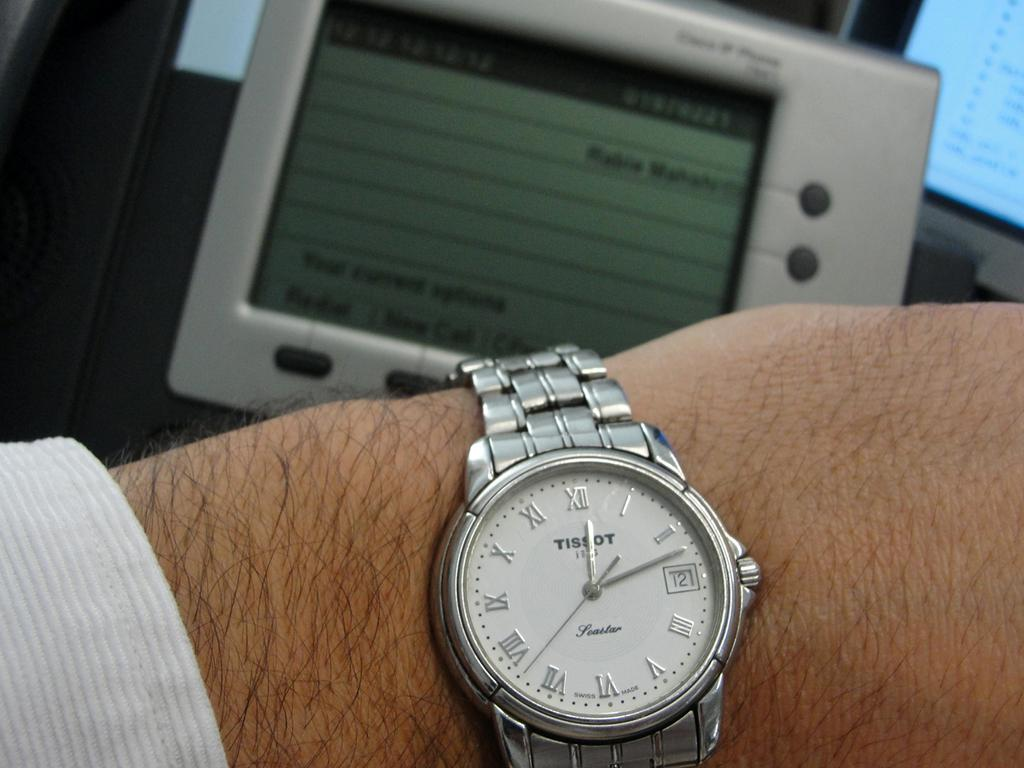<image>
Write a terse but informative summary of the picture. A Tissot watch is on someone's wrist and says today is the 12th. 